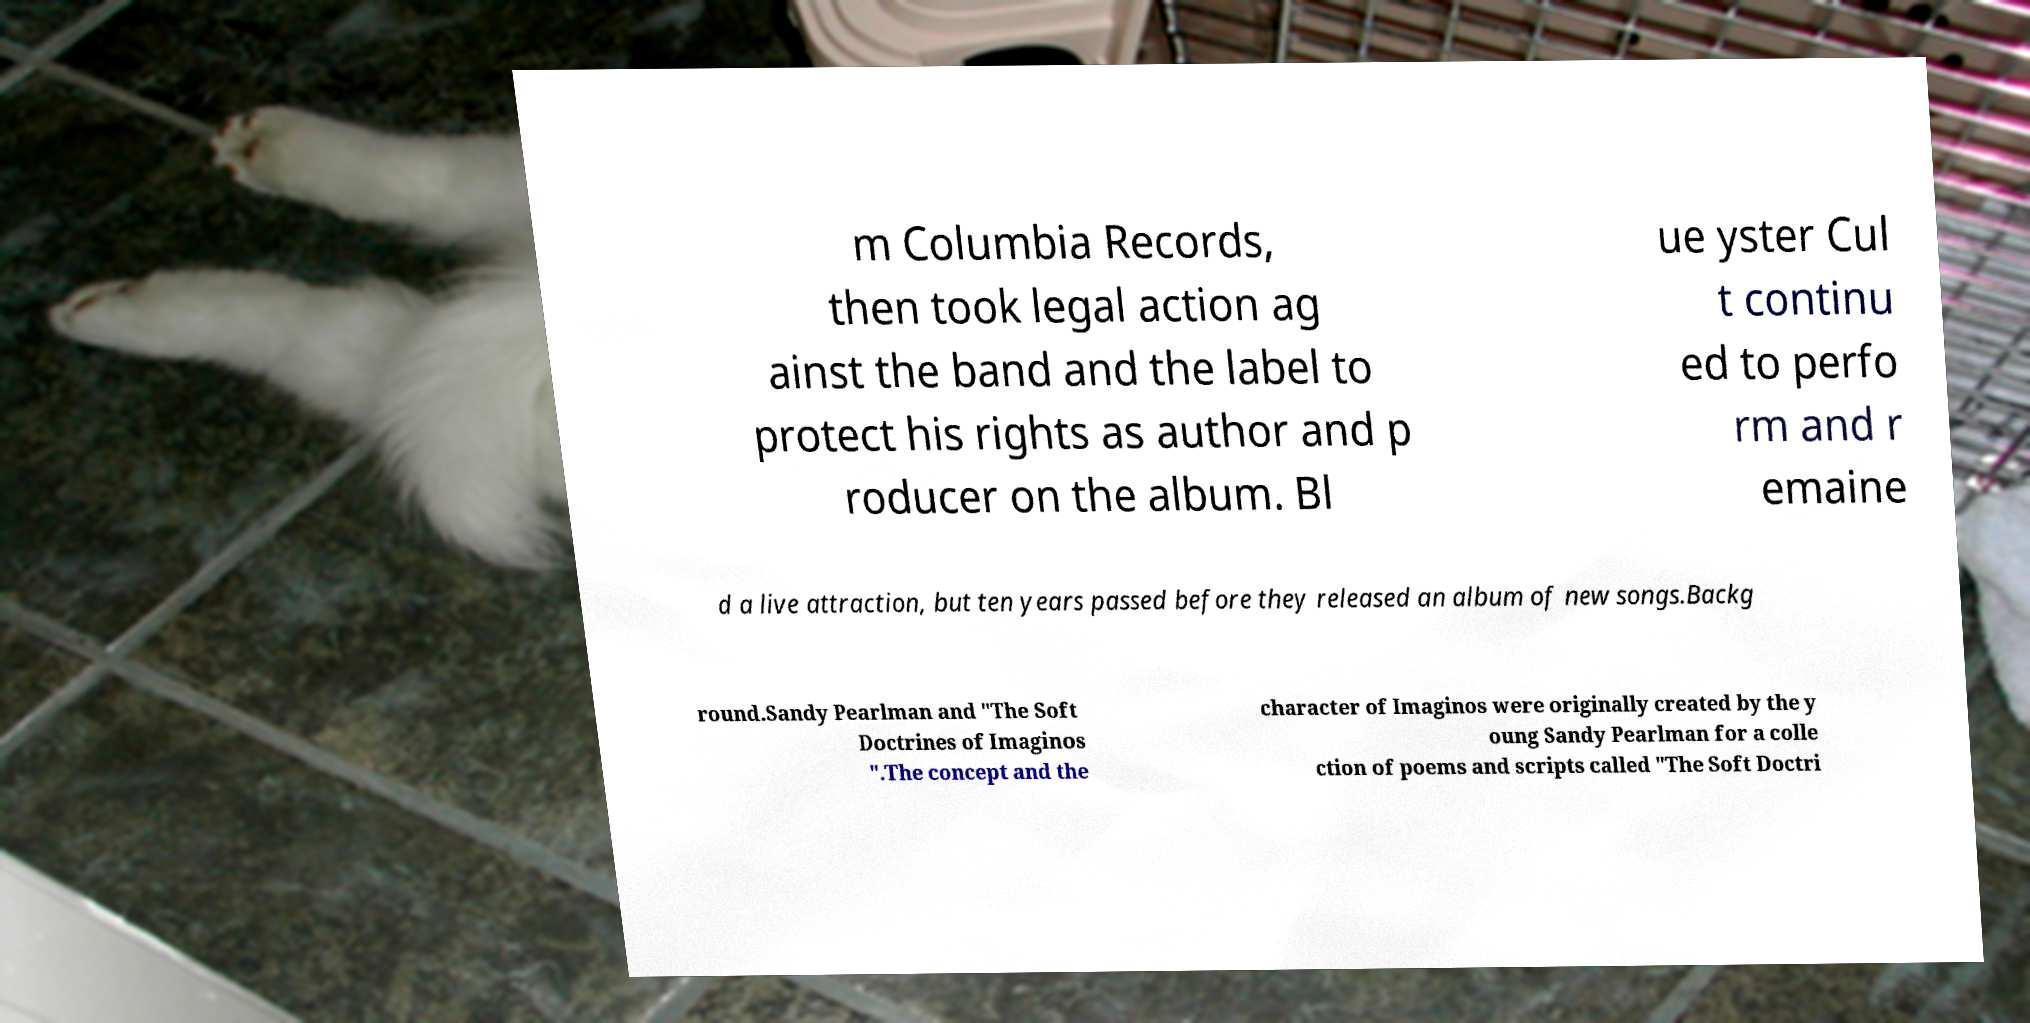What messages or text are displayed in this image? I need them in a readable, typed format. m Columbia Records, then took legal action ag ainst the band and the label to protect his rights as author and p roducer on the album. Bl ue yster Cul t continu ed to perfo rm and r emaine d a live attraction, but ten years passed before they released an album of new songs.Backg round.Sandy Pearlman and "The Soft Doctrines of Imaginos ".The concept and the character of Imaginos were originally created by the y oung Sandy Pearlman for a colle ction of poems and scripts called "The Soft Doctri 